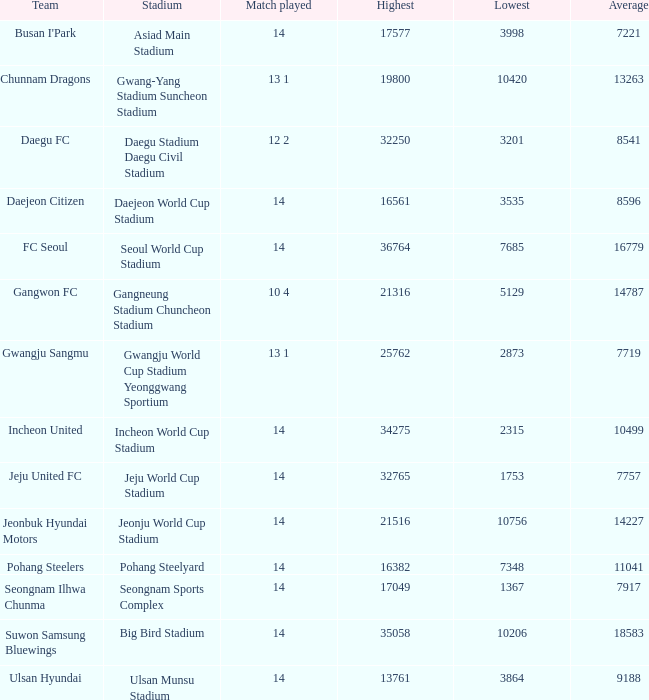Which team possesses 7757 as the average? Jeju United FC. 